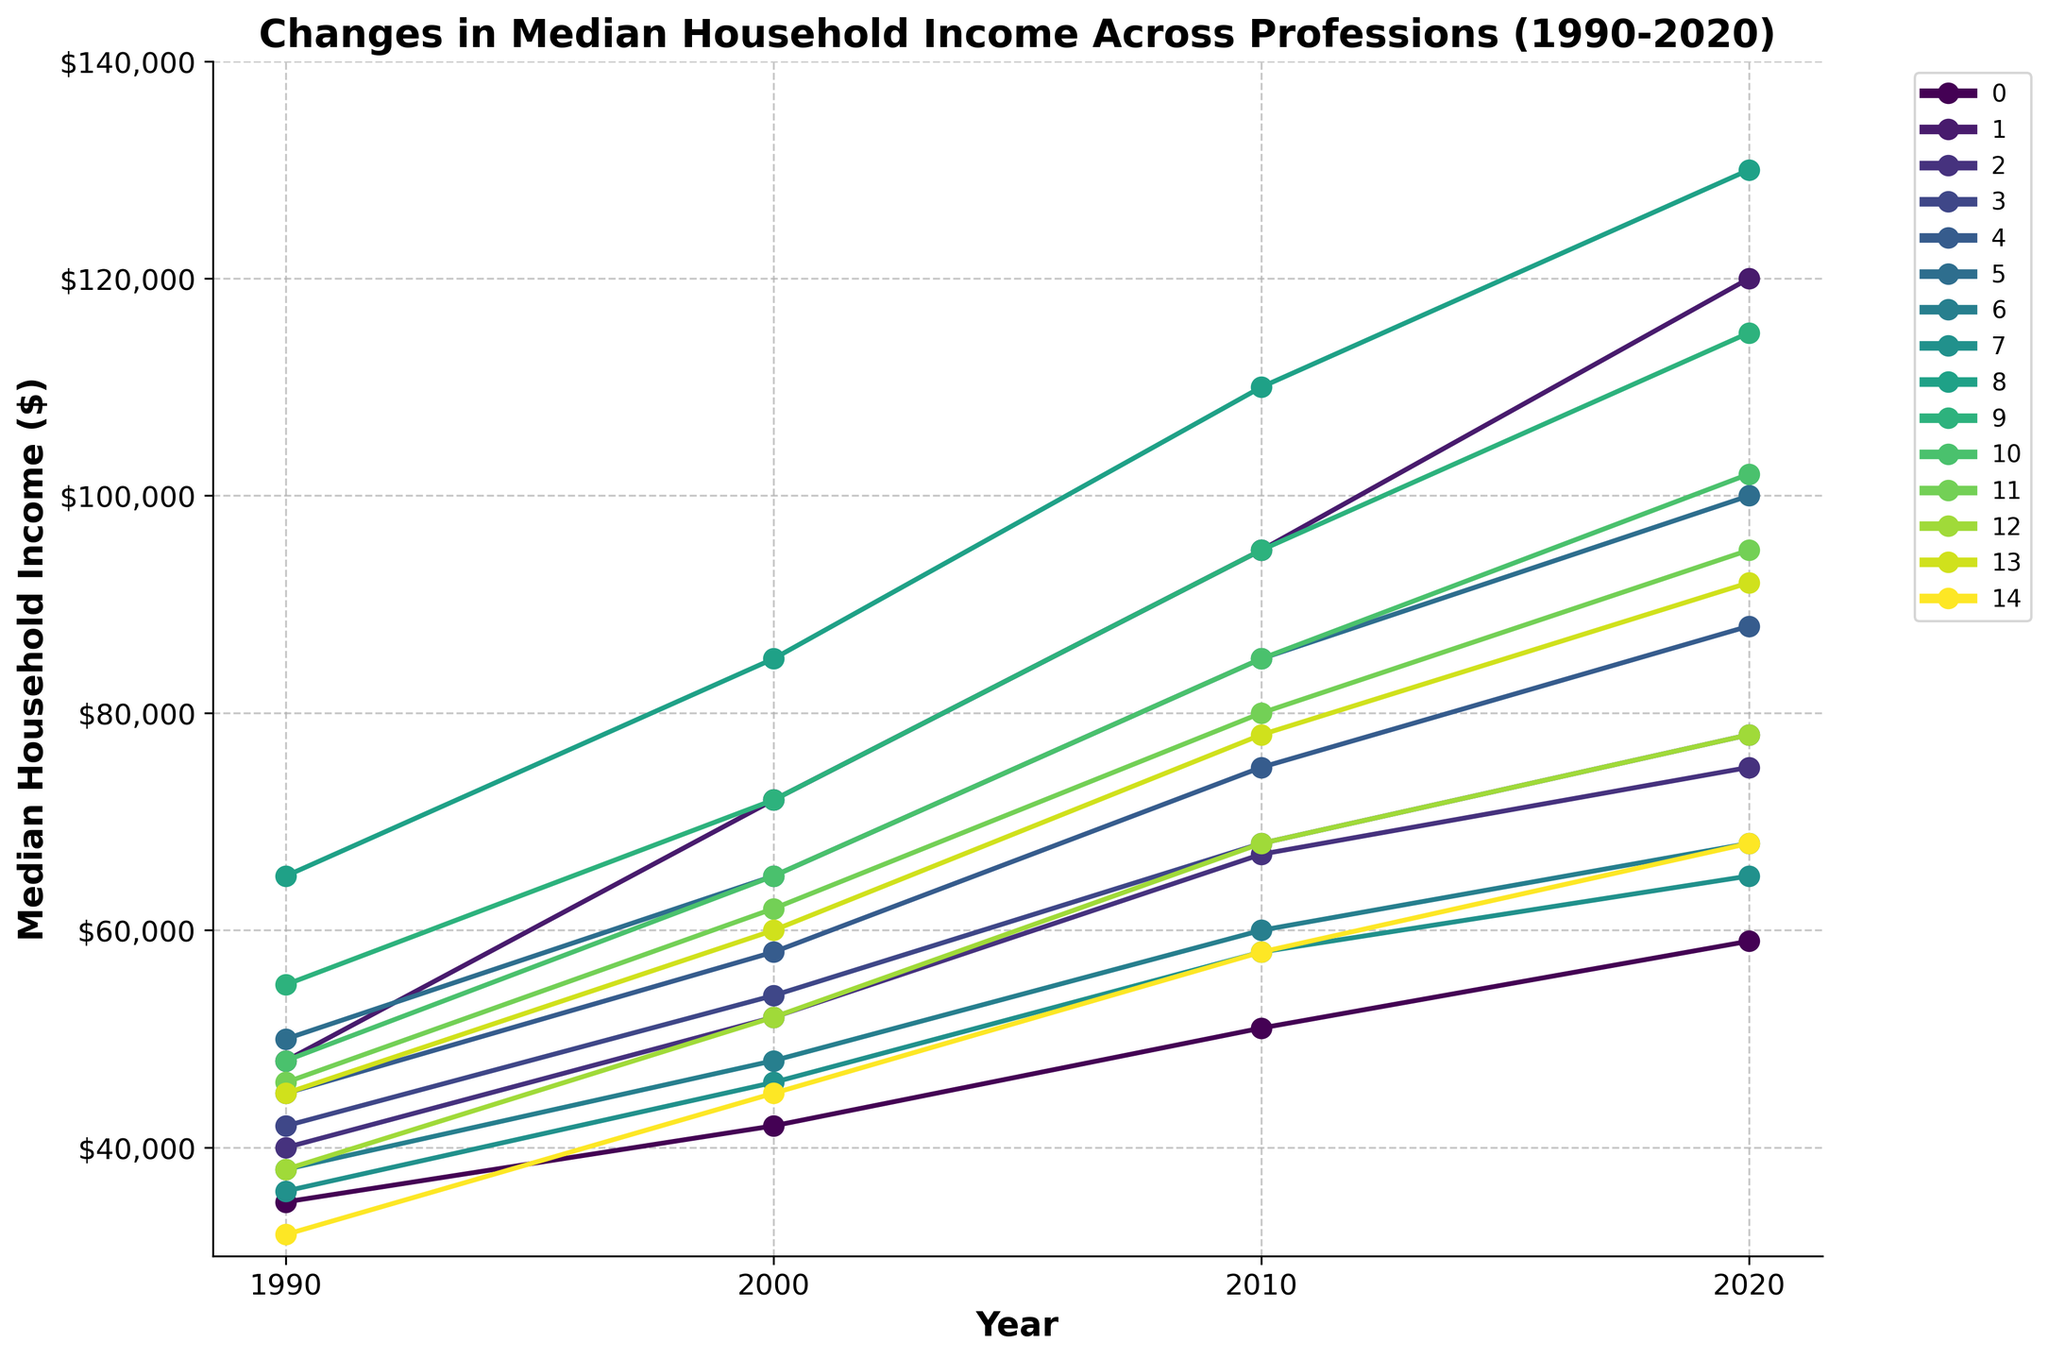What profession had the highest median household income in 2020? By looking at the far right end of the line chart, we identify the highest point. The line for "Lawyer" is the tallest, indicating the highest median income of $130,000 in 2020.
Answer: Lawyer Which profession had a higher median household income in 2020: "Mechanical Engineer" or "Human Resources Manager"? By focusing on the rightmost points, we compare the height of the lines for "Mechanical Engineer" and "Human Resources Manager." "Human Resources Manager" has a slightly taller line, indicating a higher income of $92,000 compared to $95,000 for "Mechanical Engineer."
Answer: Human Resources Manager What was the approximate increase in median household income for "Teacher" from 1990 to 2020? Look at the starting point of the "Teacher" line in 1990 and the endpoint in 2020. Subtract the 1990 value ($35,000) from the 2020 value ($59,000). The increase is $59,000 - $35,000 = $24,000.
Answer: $24,000 Between "Electrician" and "Marketing Manager," which profession had a greater relative increase in median household income over the entire period? Calculate the relative increase for both professions. For "Electrician," it is ($65,000 - $36,000)/$36,000 = 80.6%. For "Marketing Manager," it is ($100,000 - $50,000)/$50,000 = 100%. The relative increase is greater for "Marketing Manager."
Answer: Marketing Manager Which profession had the lowest median household income in 1990, and what was the amount? At the far left of the line chart, the lowest point corresponds to the profession "Graphic Designer" with a median household income of $32,000 in 1990.
Answer: Graphic Designer, $32,000 Did the median household income for "Police Officer" ever surpass that of "Registered Nurse" at any point in the given years? Check the lines for "Police Officer" and "Registered Nurse" for any intersections. At no point is the "Police Officer" line above the "Registered Nurse" line.
Answer: No What is the average median household income for "Software Engineer" across all years provided? Sum the incomes for "Software Engineer" in all years: $48,000 + $72,000 + $95,000 + $120,000 = $335,000. Then, divide by the number of data points (4): $335,000 / 4 = $83,750.
Answer: $83,750 By how much did the median household income for "Pharmacist" increase between 2000 and 2010? Subtract the 2000 value ($72,000) from the 2010 value ($95,000): $95,000 - $72,000 = $23,000.
Answer: $23,000 Which profession experienced the smallest overall increase in median household income from 1990 to 2020? Compare the increases for all professions by calculating the difference between 2020 and 1990 values. "Graphic Designer" had the smallest increase: $68,000 - $32,000 = $36,000.
Answer: Graphic Designer 